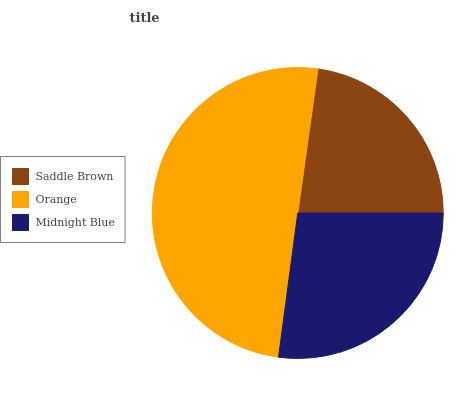Is Saddle Brown the minimum?
Answer yes or no. Yes. Is Orange the maximum?
Answer yes or no. Yes. Is Midnight Blue the minimum?
Answer yes or no. No. Is Midnight Blue the maximum?
Answer yes or no. No. Is Orange greater than Midnight Blue?
Answer yes or no. Yes. Is Midnight Blue less than Orange?
Answer yes or no. Yes. Is Midnight Blue greater than Orange?
Answer yes or no. No. Is Orange less than Midnight Blue?
Answer yes or no. No. Is Midnight Blue the high median?
Answer yes or no. Yes. Is Midnight Blue the low median?
Answer yes or no. Yes. Is Saddle Brown the high median?
Answer yes or no. No. Is Saddle Brown the low median?
Answer yes or no. No. 